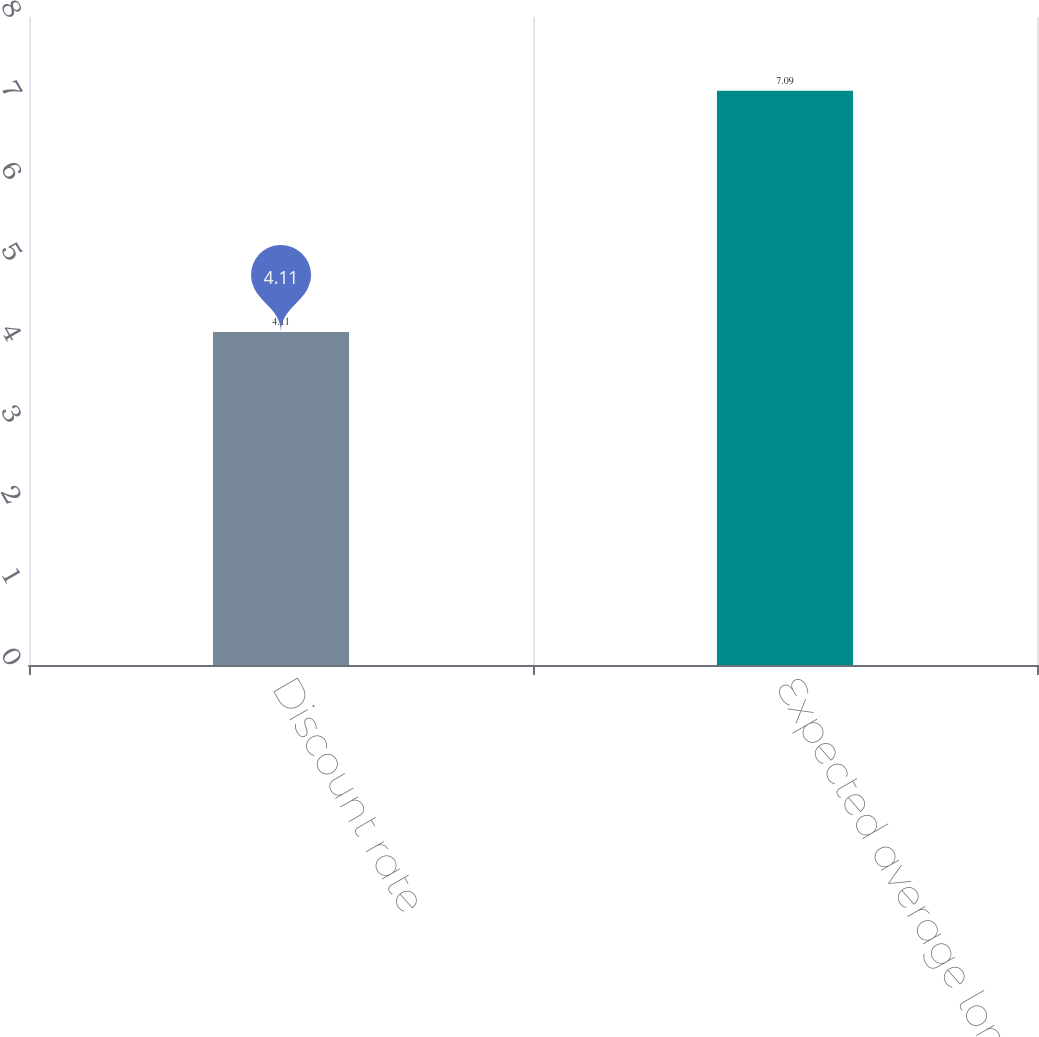Convert chart to OTSL. <chart><loc_0><loc_0><loc_500><loc_500><bar_chart><fcel>Discount rate<fcel>Expected average long-term<nl><fcel>4.11<fcel>7.09<nl></chart> 